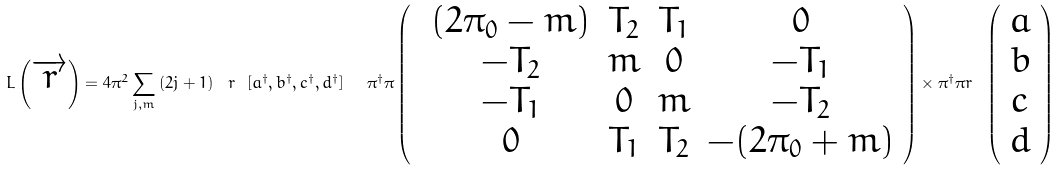Convert formula to latex. <formula><loc_0><loc_0><loc_500><loc_500>L \left ( \overrightarrow { r } \right ) = 4 \pi ^ { 2 } \sum _ { j , m } \left ( 2 j + 1 \right ) \text { } r \text { } [ a ^ { \dagger } , b ^ { \dagger } , c ^ { \dagger } , d ^ { \dagger } ] \text { \ } \pi ^ { \dagger } \pi \left ( \text {\ } \begin{array} { c c c c } ( 2 \pi _ { 0 } - m ) & T _ { 2 } & T _ { 1 } & 0 \\ - T _ { 2 } & m & 0 & - T _ { 1 } \\ - T _ { 1 } & 0 & m & - T _ { 2 } \\ 0 & T _ { 1 } & T _ { 2 } & - ( 2 \pi _ { 0 } + m ) \end{array} \right ) \times \pi ^ { \dagger } \pi r \text { } \left ( \begin{array} { c } a \\ b \\ c \\ d \end{array} \right )</formula> 